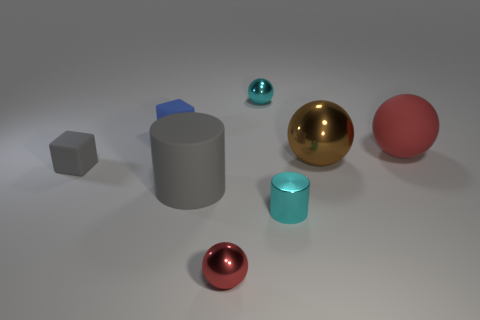Is the shape of the brown object the same as the big gray rubber object?
Your answer should be compact. No. How many cyan things are the same shape as the blue rubber thing?
Keep it short and to the point. 0. There is a tiny cyan sphere; what number of small metallic things are behind it?
Give a very brief answer. 0. There is a cylinder on the right side of the red metal sphere; is it the same color as the big rubber ball?
Your response must be concise. No. How many red balls are the same size as the brown ball?
Provide a succinct answer. 1. There is a tiny blue object that is made of the same material as the tiny gray object; what shape is it?
Ensure brevity in your answer.  Cube. Are there any blocks that have the same color as the small shiny cylinder?
Offer a terse response. No. What material is the brown object?
Make the answer very short. Metal. What number of objects are large gray objects or large blue matte balls?
Your answer should be compact. 1. What size is the red object that is in front of the big gray cylinder?
Ensure brevity in your answer.  Small. 